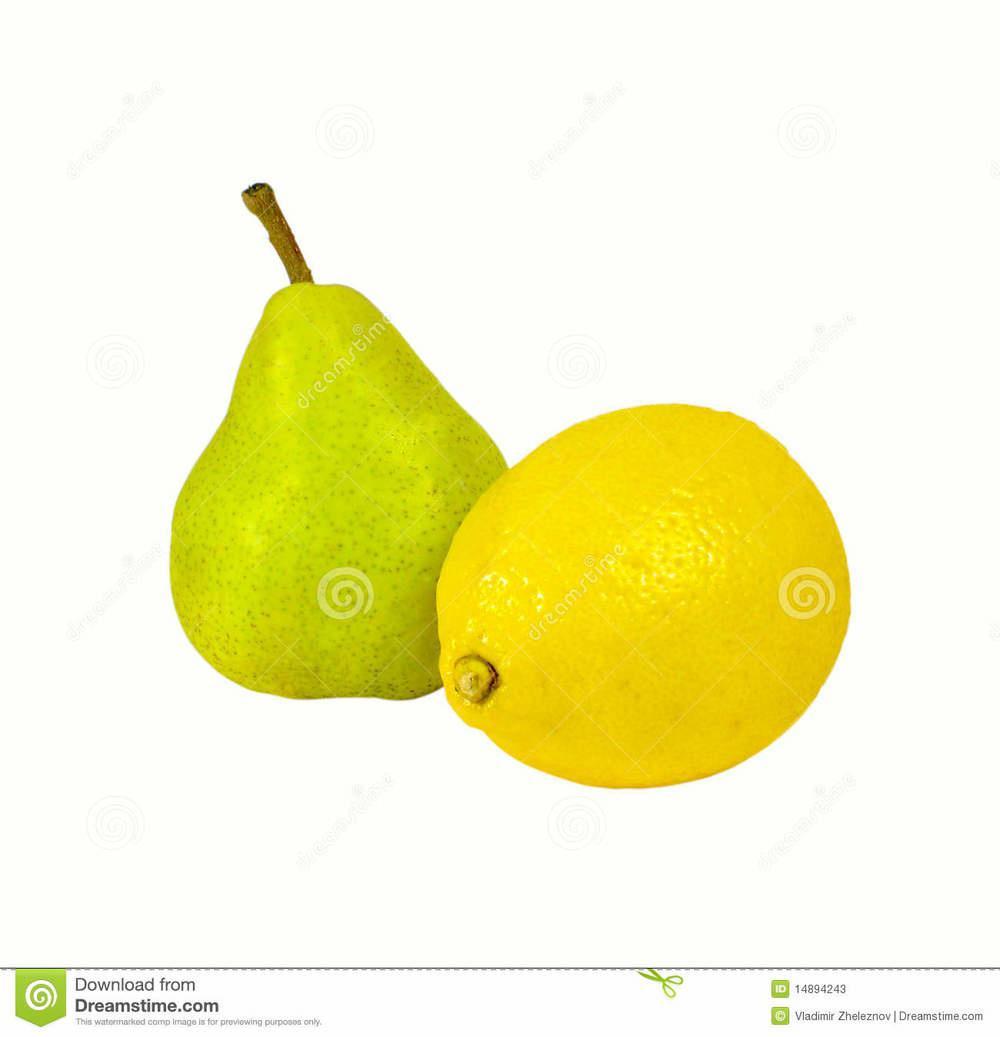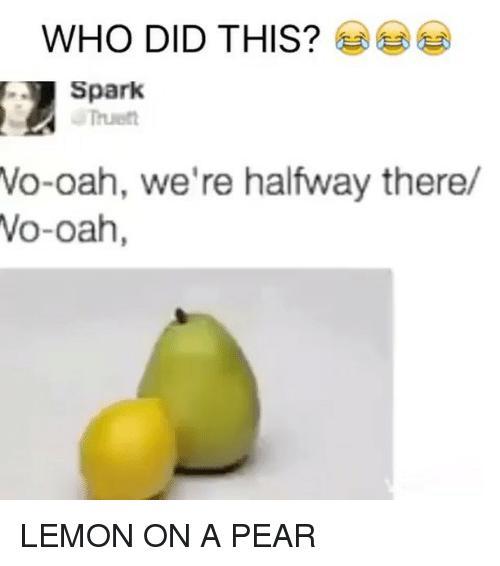The first image is the image on the left, the second image is the image on the right. Considering the images on both sides, is "In both images a lemon is in front of a pear." valid? Answer yes or no. Yes. 